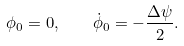Convert formula to latex. <formula><loc_0><loc_0><loc_500><loc_500>\phi _ { 0 } = 0 , \quad \dot { \phi } _ { 0 } = - \frac { \Delta \psi } { 2 } .</formula> 